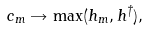<formula> <loc_0><loc_0><loc_500><loc_500>c _ { m } \rightarrow \max ( h _ { m } , h ^ { \dag } ) ,</formula> 